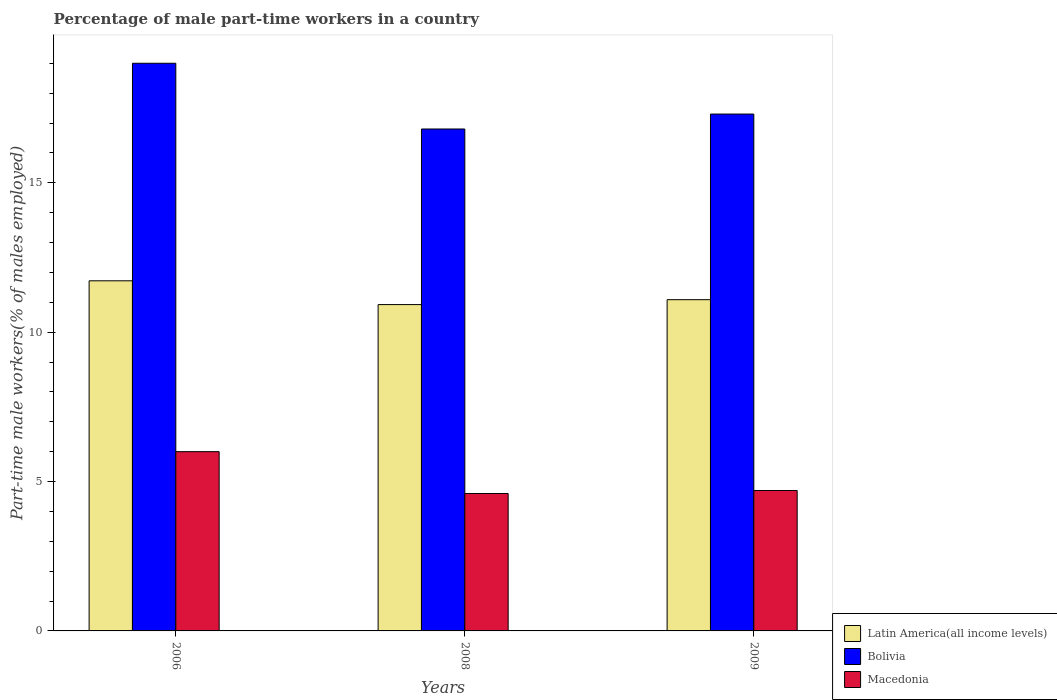How many different coloured bars are there?
Make the answer very short. 3. How many groups of bars are there?
Offer a very short reply. 3. Are the number of bars per tick equal to the number of legend labels?
Provide a succinct answer. Yes. What is the label of the 3rd group of bars from the left?
Keep it short and to the point. 2009. What is the percentage of male part-time workers in Macedonia in 2009?
Offer a terse response. 4.7. Across all years, what is the maximum percentage of male part-time workers in Latin America(all income levels)?
Keep it short and to the point. 11.72. Across all years, what is the minimum percentage of male part-time workers in Bolivia?
Make the answer very short. 16.8. In which year was the percentage of male part-time workers in Bolivia minimum?
Provide a short and direct response. 2008. What is the total percentage of male part-time workers in Macedonia in the graph?
Keep it short and to the point. 15.3. What is the difference between the percentage of male part-time workers in Bolivia in 2006 and that in 2008?
Offer a terse response. 2.2. What is the difference between the percentage of male part-time workers in Latin America(all income levels) in 2008 and the percentage of male part-time workers in Macedonia in 2006?
Offer a terse response. 4.92. What is the average percentage of male part-time workers in Bolivia per year?
Your answer should be compact. 17.7. In the year 2009, what is the difference between the percentage of male part-time workers in Latin America(all income levels) and percentage of male part-time workers in Bolivia?
Ensure brevity in your answer.  -6.21. What is the ratio of the percentage of male part-time workers in Latin America(all income levels) in 2006 to that in 2008?
Offer a very short reply. 1.07. What is the difference between the highest and the second highest percentage of male part-time workers in Macedonia?
Make the answer very short. 1.3. What is the difference between the highest and the lowest percentage of male part-time workers in Macedonia?
Offer a terse response. 1.4. In how many years, is the percentage of male part-time workers in Macedonia greater than the average percentage of male part-time workers in Macedonia taken over all years?
Make the answer very short. 1. What does the 1st bar from the left in 2009 represents?
Your answer should be very brief. Latin America(all income levels). What does the 3rd bar from the right in 2009 represents?
Offer a very short reply. Latin America(all income levels). How many bars are there?
Your answer should be compact. 9. How many years are there in the graph?
Provide a short and direct response. 3. Are the values on the major ticks of Y-axis written in scientific E-notation?
Your answer should be very brief. No. Does the graph contain any zero values?
Give a very brief answer. No. Does the graph contain grids?
Ensure brevity in your answer.  No. Where does the legend appear in the graph?
Your answer should be compact. Bottom right. How are the legend labels stacked?
Provide a succinct answer. Vertical. What is the title of the graph?
Your response must be concise. Percentage of male part-time workers in a country. Does "Kuwait" appear as one of the legend labels in the graph?
Keep it short and to the point. No. What is the label or title of the Y-axis?
Provide a short and direct response. Part-time male workers(% of males employed). What is the Part-time male workers(% of males employed) of Latin America(all income levels) in 2006?
Provide a short and direct response. 11.72. What is the Part-time male workers(% of males employed) of Bolivia in 2006?
Ensure brevity in your answer.  19. What is the Part-time male workers(% of males employed) in Latin America(all income levels) in 2008?
Ensure brevity in your answer.  10.92. What is the Part-time male workers(% of males employed) in Bolivia in 2008?
Your answer should be very brief. 16.8. What is the Part-time male workers(% of males employed) in Macedonia in 2008?
Offer a terse response. 4.6. What is the Part-time male workers(% of males employed) in Latin America(all income levels) in 2009?
Ensure brevity in your answer.  11.09. What is the Part-time male workers(% of males employed) of Bolivia in 2009?
Keep it short and to the point. 17.3. What is the Part-time male workers(% of males employed) of Macedonia in 2009?
Make the answer very short. 4.7. Across all years, what is the maximum Part-time male workers(% of males employed) of Latin America(all income levels)?
Your response must be concise. 11.72. Across all years, what is the minimum Part-time male workers(% of males employed) in Latin America(all income levels)?
Offer a terse response. 10.92. Across all years, what is the minimum Part-time male workers(% of males employed) of Bolivia?
Offer a terse response. 16.8. Across all years, what is the minimum Part-time male workers(% of males employed) of Macedonia?
Your answer should be compact. 4.6. What is the total Part-time male workers(% of males employed) of Latin America(all income levels) in the graph?
Ensure brevity in your answer.  33.73. What is the total Part-time male workers(% of males employed) of Bolivia in the graph?
Offer a terse response. 53.1. What is the difference between the Part-time male workers(% of males employed) in Latin America(all income levels) in 2006 and that in 2008?
Keep it short and to the point. 0.8. What is the difference between the Part-time male workers(% of males employed) of Bolivia in 2006 and that in 2008?
Offer a very short reply. 2.2. What is the difference between the Part-time male workers(% of males employed) in Macedonia in 2006 and that in 2008?
Ensure brevity in your answer.  1.4. What is the difference between the Part-time male workers(% of males employed) of Latin America(all income levels) in 2006 and that in 2009?
Ensure brevity in your answer.  0.63. What is the difference between the Part-time male workers(% of males employed) of Macedonia in 2006 and that in 2009?
Your response must be concise. 1.3. What is the difference between the Part-time male workers(% of males employed) of Latin America(all income levels) in 2008 and that in 2009?
Provide a short and direct response. -0.16. What is the difference between the Part-time male workers(% of males employed) in Latin America(all income levels) in 2006 and the Part-time male workers(% of males employed) in Bolivia in 2008?
Give a very brief answer. -5.08. What is the difference between the Part-time male workers(% of males employed) of Latin America(all income levels) in 2006 and the Part-time male workers(% of males employed) of Macedonia in 2008?
Provide a short and direct response. 7.12. What is the difference between the Part-time male workers(% of males employed) in Bolivia in 2006 and the Part-time male workers(% of males employed) in Macedonia in 2008?
Ensure brevity in your answer.  14.4. What is the difference between the Part-time male workers(% of males employed) in Latin America(all income levels) in 2006 and the Part-time male workers(% of males employed) in Bolivia in 2009?
Ensure brevity in your answer.  -5.58. What is the difference between the Part-time male workers(% of males employed) of Latin America(all income levels) in 2006 and the Part-time male workers(% of males employed) of Macedonia in 2009?
Provide a short and direct response. 7.02. What is the difference between the Part-time male workers(% of males employed) of Latin America(all income levels) in 2008 and the Part-time male workers(% of males employed) of Bolivia in 2009?
Provide a succinct answer. -6.38. What is the difference between the Part-time male workers(% of males employed) of Latin America(all income levels) in 2008 and the Part-time male workers(% of males employed) of Macedonia in 2009?
Make the answer very short. 6.22. What is the difference between the Part-time male workers(% of males employed) in Bolivia in 2008 and the Part-time male workers(% of males employed) in Macedonia in 2009?
Give a very brief answer. 12.1. What is the average Part-time male workers(% of males employed) of Latin America(all income levels) per year?
Offer a very short reply. 11.24. What is the average Part-time male workers(% of males employed) in Bolivia per year?
Offer a very short reply. 17.7. What is the average Part-time male workers(% of males employed) in Macedonia per year?
Offer a very short reply. 5.1. In the year 2006, what is the difference between the Part-time male workers(% of males employed) in Latin America(all income levels) and Part-time male workers(% of males employed) in Bolivia?
Offer a terse response. -7.28. In the year 2006, what is the difference between the Part-time male workers(% of males employed) of Latin America(all income levels) and Part-time male workers(% of males employed) of Macedonia?
Provide a succinct answer. 5.72. In the year 2006, what is the difference between the Part-time male workers(% of males employed) of Bolivia and Part-time male workers(% of males employed) of Macedonia?
Provide a succinct answer. 13. In the year 2008, what is the difference between the Part-time male workers(% of males employed) of Latin America(all income levels) and Part-time male workers(% of males employed) of Bolivia?
Offer a very short reply. -5.88. In the year 2008, what is the difference between the Part-time male workers(% of males employed) of Latin America(all income levels) and Part-time male workers(% of males employed) of Macedonia?
Give a very brief answer. 6.32. In the year 2008, what is the difference between the Part-time male workers(% of males employed) in Bolivia and Part-time male workers(% of males employed) in Macedonia?
Keep it short and to the point. 12.2. In the year 2009, what is the difference between the Part-time male workers(% of males employed) of Latin America(all income levels) and Part-time male workers(% of males employed) of Bolivia?
Your answer should be compact. -6.21. In the year 2009, what is the difference between the Part-time male workers(% of males employed) in Latin America(all income levels) and Part-time male workers(% of males employed) in Macedonia?
Offer a very short reply. 6.39. In the year 2009, what is the difference between the Part-time male workers(% of males employed) of Bolivia and Part-time male workers(% of males employed) of Macedonia?
Offer a terse response. 12.6. What is the ratio of the Part-time male workers(% of males employed) in Latin America(all income levels) in 2006 to that in 2008?
Provide a succinct answer. 1.07. What is the ratio of the Part-time male workers(% of males employed) in Bolivia in 2006 to that in 2008?
Offer a very short reply. 1.13. What is the ratio of the Part-time male workers(% of males employed) of Macedonia in 2006 to that in 2008?
Offer a terse response. 1.3. What is the ratio of the Part-time male workers(% of males employed) of Latin America(all income levels) in 2006 to that in 2009?
Your answer should be compact. 1.06. What is the ratio of the Part-time male workers(% of males employed) in Bolivia in 2006 to that in 2009?
Your response must be concise. 1.1. What is the ratio of the Part-time male workers(% of males employed) in Macedonia in 2006 to that in 2009?
Your answer should be very brief. 1.28. What is the ratio of the Part-time male workers(% of males employed) in Latin America(all income levels) in 2008 to that in 2009?
Give a very brief answer. 0.99. What is the ratio of the Part-time male workers(% of males employed) in Bolivia in 2008 to that in 2009?
Your response must be concise. 0.97. What is the ratio of the Part-time male workers(% of males employed) in Macedonia in 2008 to that in 2009?
Provide a succinct answer. 0.98. What is the difference between the highest and the second highest Part-time male workers(% of males employed) of Latin America(all income levels)?
Give a very brief answer. 0.63. What is the difference between the highest and the second highest Part-time male workers(% of males employed) in Macedonia?
Your response must be concise. 1.3. What is the difference between the highest and the lowest Part-time male workers(% of males employed) in Latin America(all income levels)?
Ensure brevity in your answer.  0.8. What is the difference between the highest and the lowest Part-time male workers(% of males employed) in Macedonia?
Ensure brevity in your answer.  1.4. 